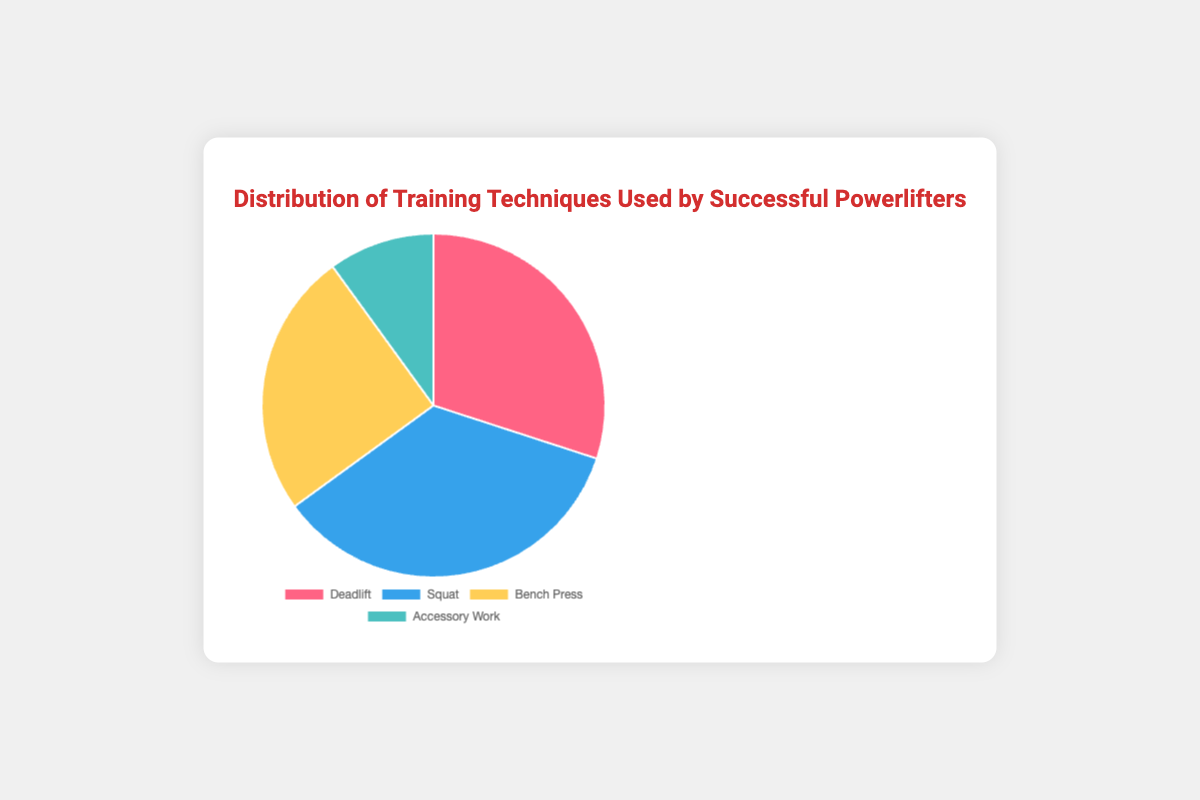What percentage of training is allocated to squats compared to deadlifts? The pie chart shows that 35% of training is allocated to squats and 30% to deadlifts. To compare, you can see that squats have a higher allocation than deadlifts by observing their respective proportions in the chart.
Answer: 35% vs 30% Which training technique has the lowest allocation, and what is its percentage? By inspecting the pie chart, you can identify that accessory work is allocated the smallest portion, and its proportion is shown as 10%.
Answer: Accessory work, 10% What is the combined percentage of training allocated to bench press and accessory work? According to the pie chart, bench press accounts for 25% and accessory work accounts for 10%. By summing these two values (25 + 10), you get the total combined percentage.
Answer: 35% Which training technique has the highest allocation? Observing the proportions in the pie chart, you'll see that the squat technique takes up the largest slice, representing 35% of the total training allocation.
Answer: Squat How much more percentage of training is allocated to squats than to accessory work? From the pie chart, squats account for 35% of the training and accessory work accounts for 10%. The difference between these percentages is calculated as 35 - 10 = 25%.
Answer: 25% Is the percentage of training for deadlifts greater than that for bench press? The pie chart indicates that deadlifts account for 30% of the training while bench press accounts for 25%. By comparing these percentages, you see that deadlifts have a higher percentage.
Answer: Yes What percentage of training is allocated to giving deadlift and bench press combined? To find the combined allocation of deadlift and bench press, you add their percentages from the pie chart, which are 30% and 25% respectively. 30 + 25 = 55%.
Answer: 55% If we combine deadlift, squat, and bench press, what percentage of the total training does that represent? By summing up the individual percentages for deadlift (30%), squat (35%), and bench press (25%) from the pie chart, the total combined percentage is 30 + 35 + 25 = 90%.
Answer: 90% What color represents the highest percentage training technique in the chart? By examining the pie chart, you notice that the segment representing the highest percentage (squat, 35%) is colored in blue.
Answer: Blue What is the difference in percentage between the highest and lowest allocation in training techniques? The highest allocation is for squats at 35% and the lowest for accessory work at 10%. The difference between these two percentages is calculated as 35 - 10 = 25%.
Answer: 25% 